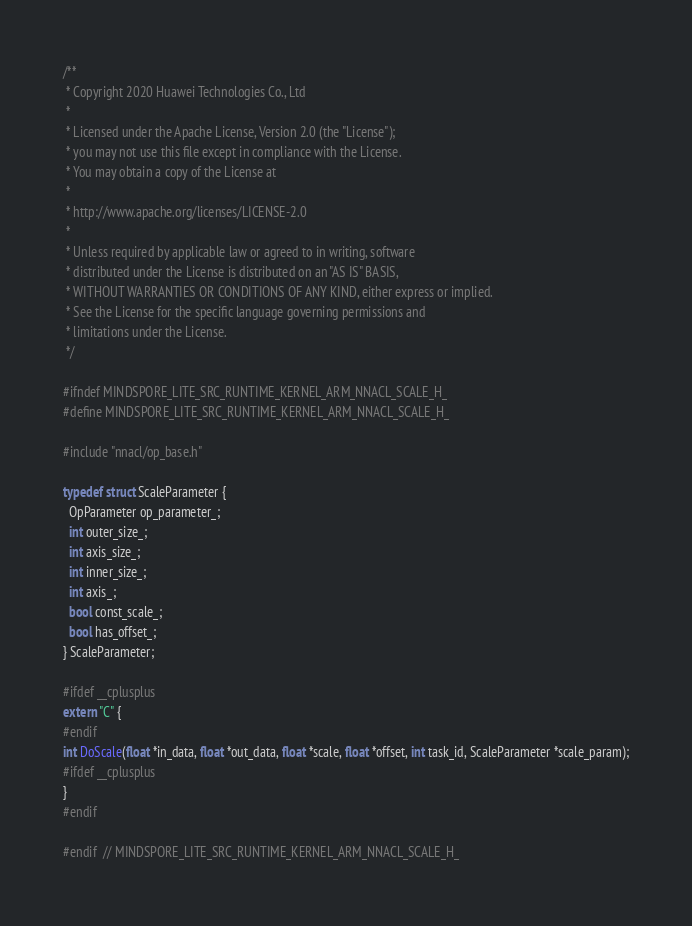<code> <loc_0><loc_0><loc_500><loc_500><_C_>/**
 * Copyright 2020 Huawei Technologies Co., Ltd
 *
 * Licensed under the Apache License, Version 2.0 (the "License");
 * you may not use this file except in compliance with the License.
 * You may obtain a copy of the License at
 *
 * http://www.apache.org/licenses/LICENSE-2.0
 *
 * Unless required by applicable law or agreed to in writing, software
 * distributed under the License is distributed on an "AS IS" BASIS,
 * WITHOUT WARRANTIES OR CONDITIONS OF ANY KIND, either express or implied.
 * See the License for the specific language governing permissions and
 * limitations under the License.
 */

#ifndef MINDSPORE_LITE_SRC_RUNTIME_KERNEL_ARM_NNACL_SCALE_H_
#define MINDSPORE_LITE_SRC_RUNTIME_KERNEL_ARM_NNACL_SCALE_H_

#include "nnacl/op_base.h"

typedef struct ScaleParameter {
  OpParameter op_parameter_;
  int outer_size_;
  int axis_size_;
  int inner_size_;
  int axis_;
  bool const_scale_;
  bool has_offset_;
} ScaleParameter;

#ifdef __cplusplus
extern "C" {
#endif
int DoScale(float *in_data, float *out_data, float *scale, float *offset, int task_id, ScaleParameter *scale_param);
#ifdef __cplusplus
}
#endif

#endif  // MINDSPORE_LITE_SRC_RUNTIME_KERNEL_ARM_NNACL_SCALE_H_
</code> 